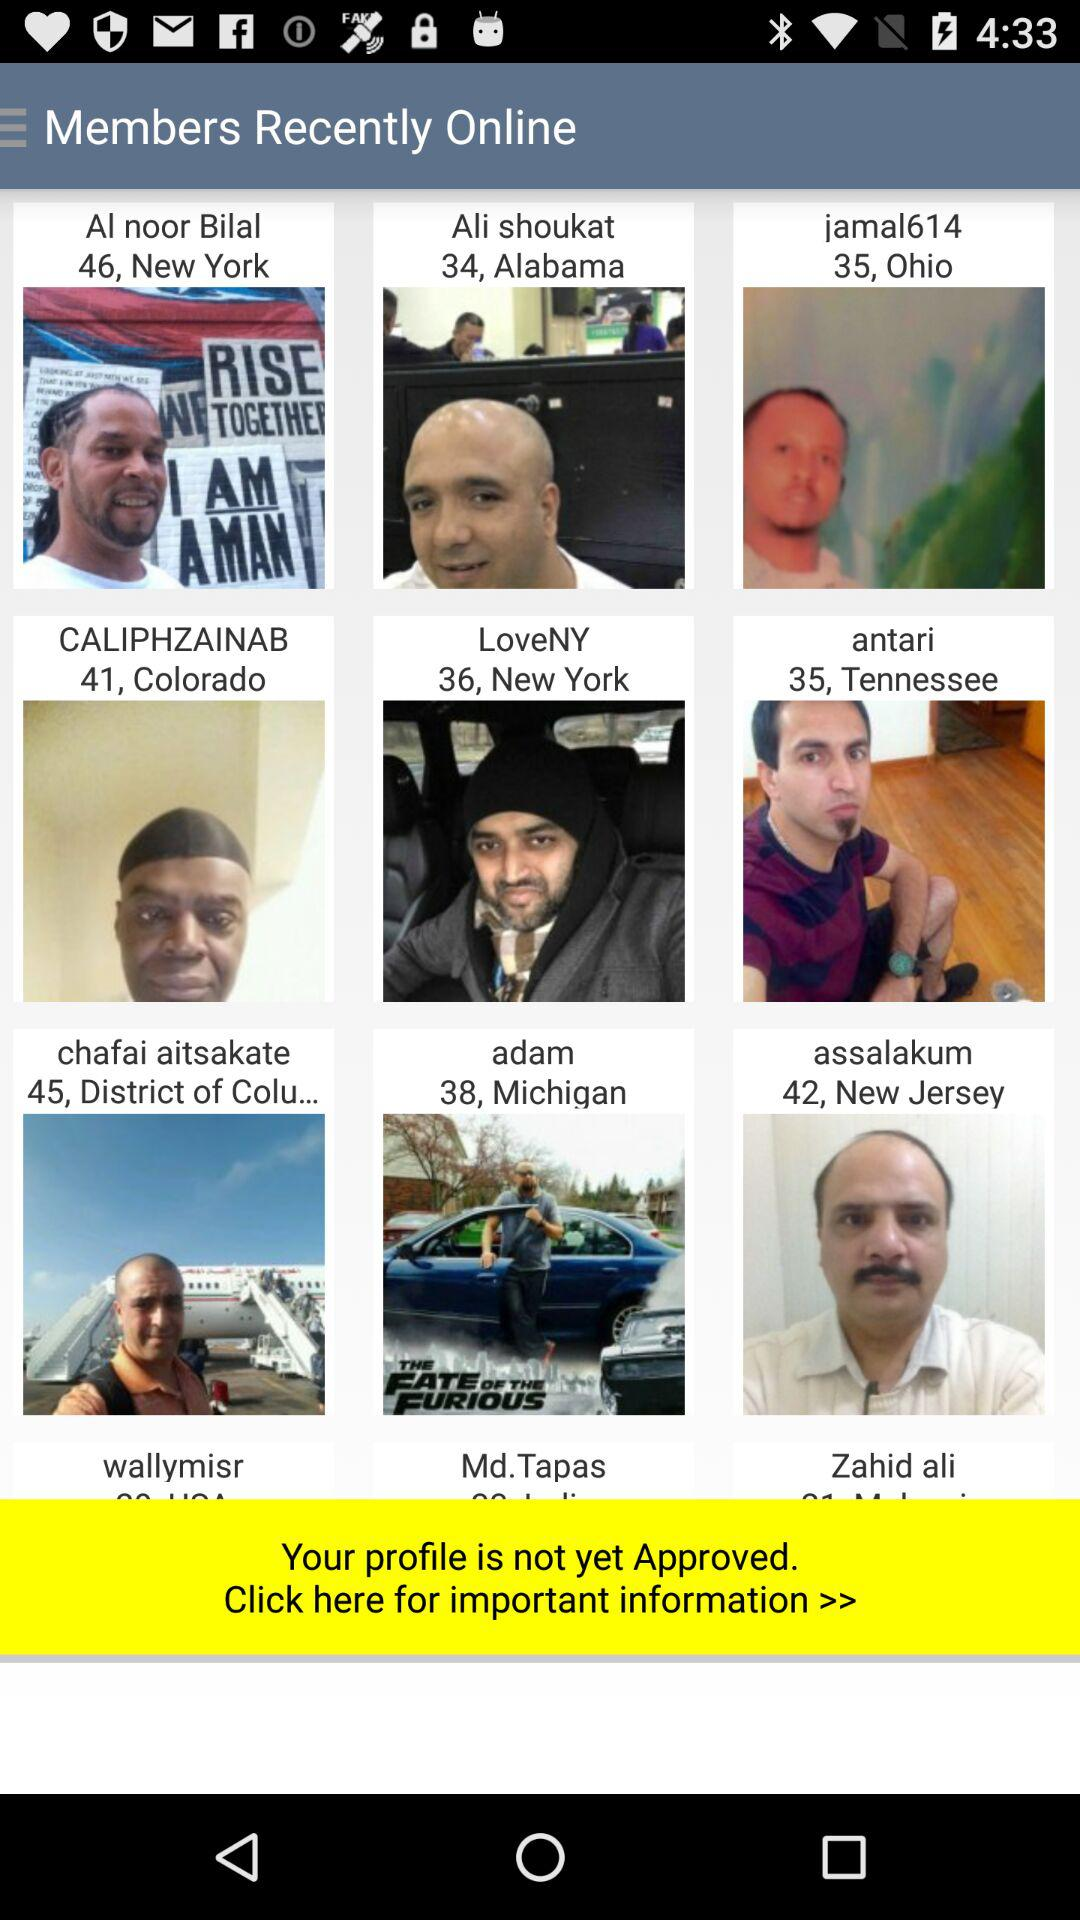From where "jamal614" belongs to? "jamal614" belongs to Ohio. 